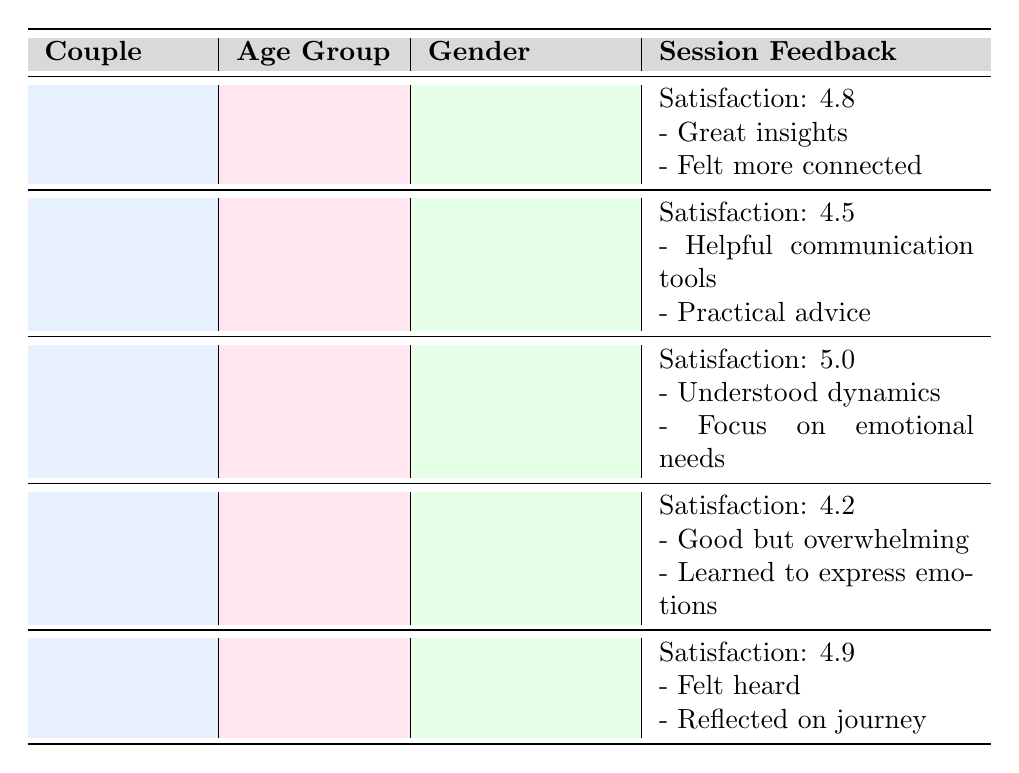What is the satisfaction rating of Couple C? Couple C has a satisfaction rating listed in the table, which is 5.0.
Answer: 5.0 Which couple provided the comment about feeling more connected? The comment about feeling more connected is noted under Couple A's feedback.
Answer: Couple A How many couples have a satisfaction rating of 4.5 or higher? There are 4 couples with a satisfaction rating of 4.5 or higher: Couple A (4.8), Couple B (4.5), Couple C (5.0), and Couple E (4.9). Couple D has a rating of 4.2, which does not meet this criterion.
Answer: 4 What is the average satisfaction rating of Couples A, B, and E? The satisfaction ratings of Couples A, B, and E are 4.8, 4.5, and 4.9, respectively. The sum is 4.8 + 4.5 + 4.9 = 14.2. Dividing by the number of couples (3), the average is 14.2 / 3 = 4.73.
Answer: 4.73 Does any couple have the same gender for both partners? Yes, Couple C (Female-Female) and Couple D (Male-Male) both have the same gender for both partners.
Answer: Yes Which age group has the highest satisfaction rating? Looking at the satisfaction ratings by age group, Couple C (45-54) has the highest rating of 5.0, which is the maximum across all age groups in the table.
Answer: 45-54 What feedback did Couple B provide regarding the session? Couple B provided comments that included helpful communication tools and practical advice given, which are listed in their session feedback.
Answer: Helpful communication tools and practical advice Which couple reported feeling overwhelmed during the session? Couple D reported feeling overwhelmed, as indicated in their feedback, which states that the insights were good but a bit overwhelming.
Answer: Couple D 